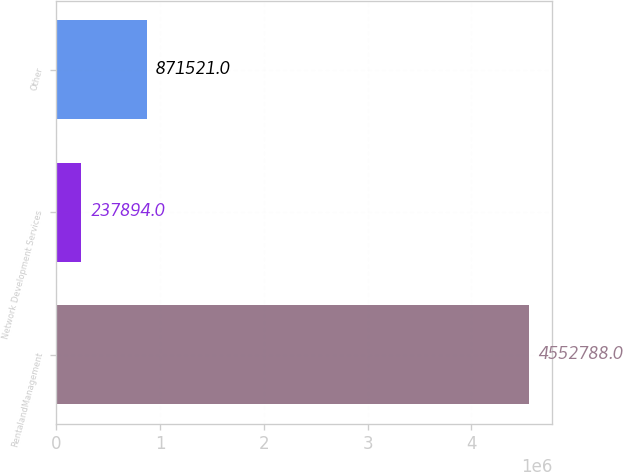Convert chart to OTSL. <chart><loc_0><loc_0><loc_500><loc_500><bar_chart><fcel>RentalandManagement<fcel>Network Development Services<fcel>Other<nl><fcel>4.55279e+06<fcel>237894<fcel>871521<nl></chart> 